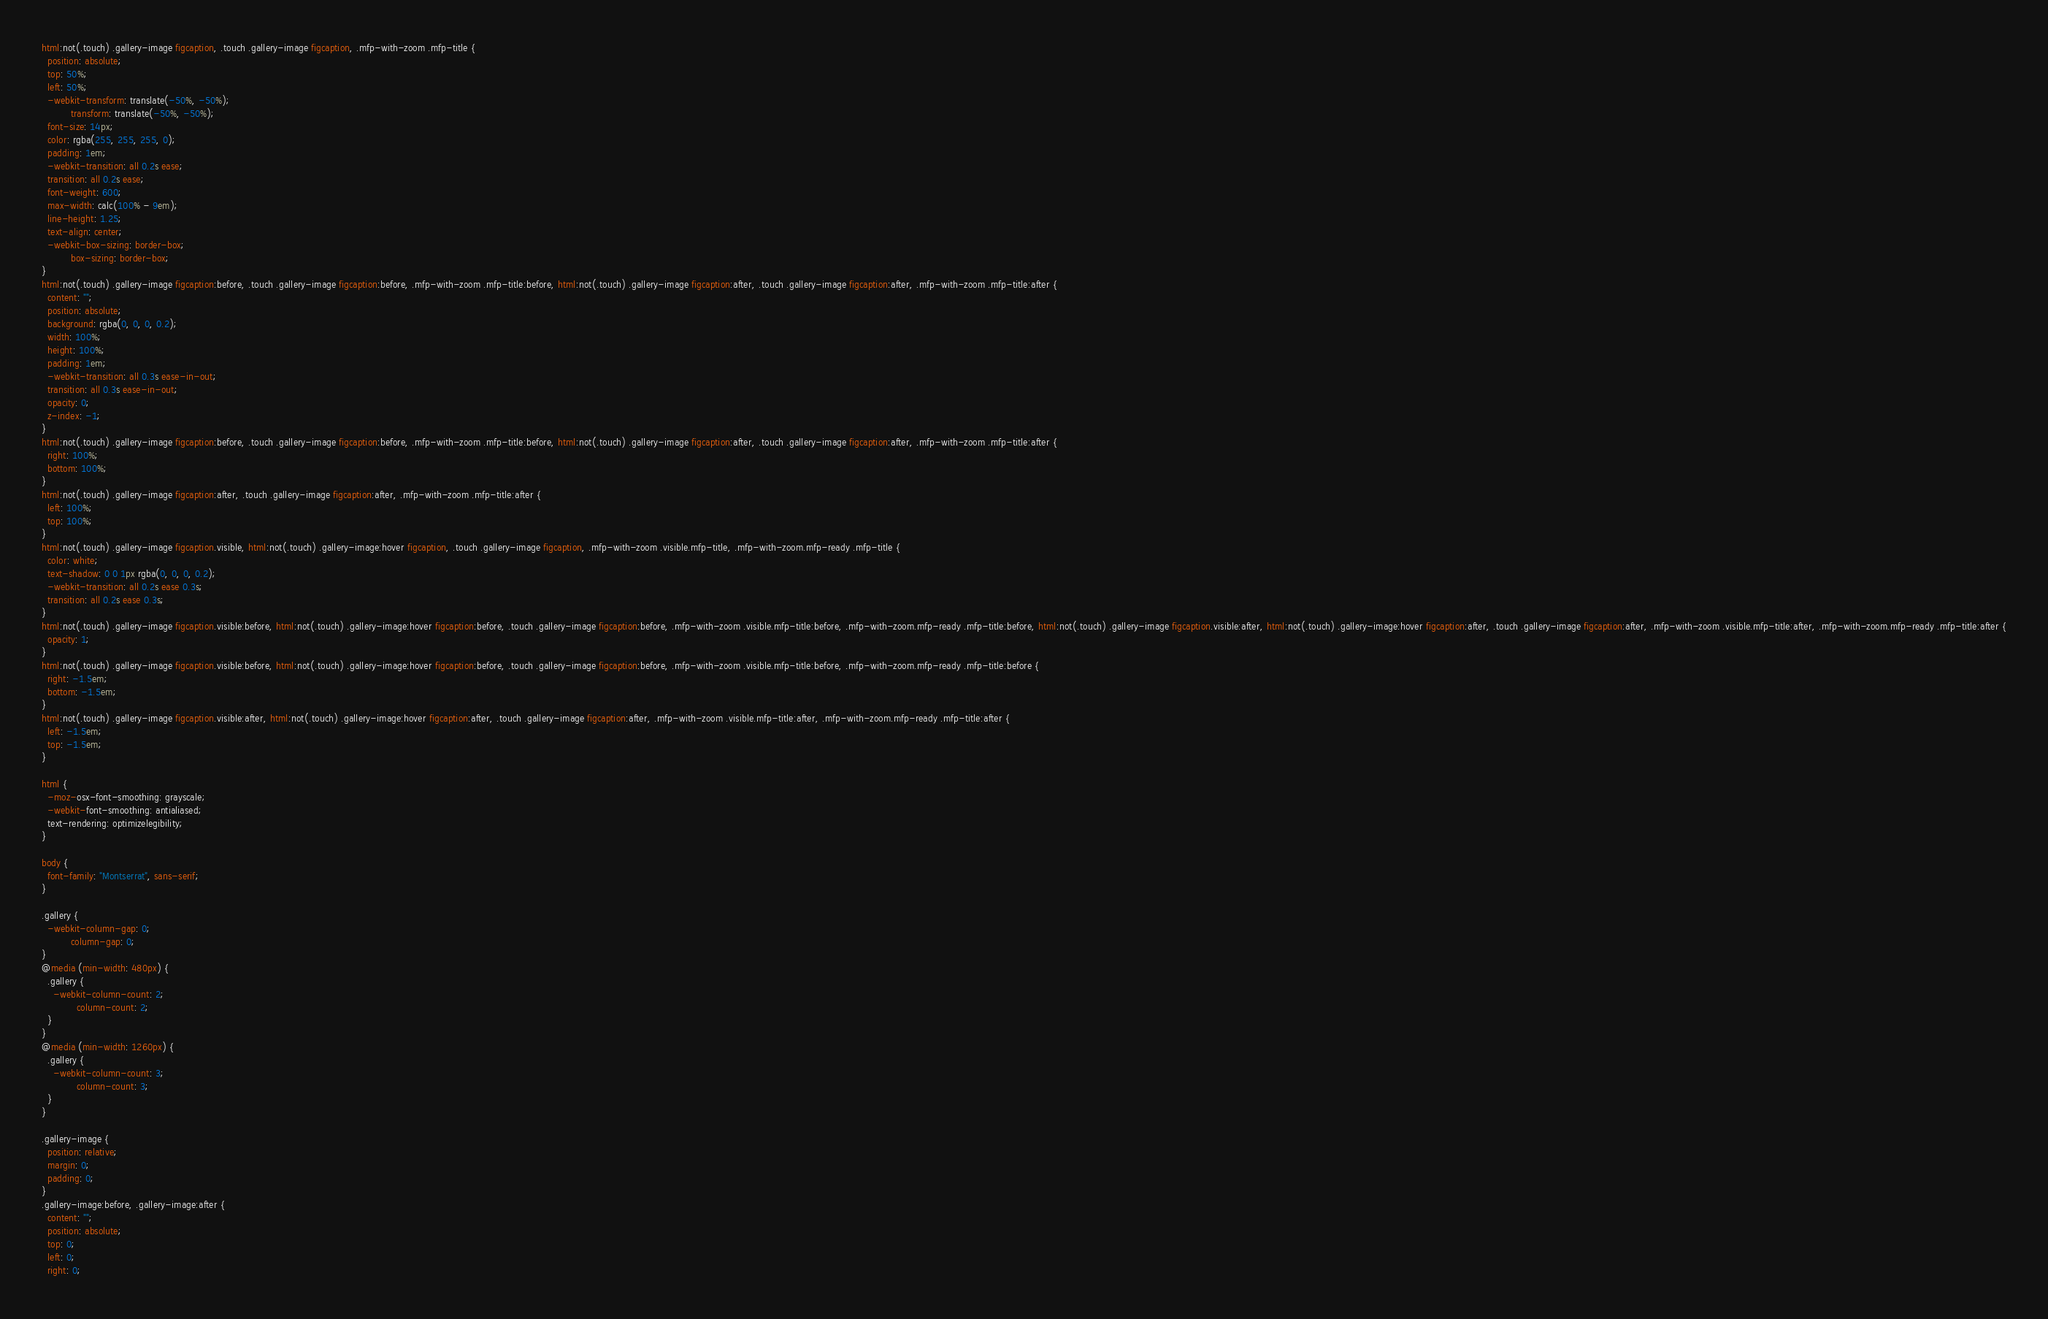Convert code to text. <code><loc_0><loc_0><loc_500><loc_500><_CSS_>html:not(.touch) .gallery-image figcaption, .touch .gallery-image figcaption, .mfp-with-zoom .mfp-title {
  position: absolute;
  top: 50%;
  left: 50%;
  -webkit-transform: translate(-50%, -50%);
          transform: translate(-50%, -50%);
  font-size: 14px;
  color: rgba(255, 255, 255, 0);
  padding: 1em;
  -webkit-transition: all 0.2s ease;
  transition: all 0.2s ease;
  font-weight: 600;
  max-width: calc(100% - 9em);
  line-height: 1.25;
  text-align: center;
  -webkit-box-sizing: border-box;
          box-sizing: border-box;
}
html:not(.touch) .gallery-image figcaption:before, .touch .gallery-image figcaption:before, .mfp-with-zoom .mfp-title:before, html:not(.touch) .gallery-image figcaption:after, .touch .gallery-image figcaption:after, .mfp-with-zoom .mfp-title:after {
  content: "";
  position: absolute;
  background: rgba(0, 0, 0, 0.2);
  width: 100%;
  height: 100%;
  padding: 1em;
  -webkit-transition: all 0.3s ease-in-out;
  transition: all 0.3s ease-in-out;
  opacity: 0;
  z-index: -1;
}
html:not(.touch) .gallery-image figcaption:before, .touch .gallery-image figcaption:before, .mfp-with-zoom .mfp-title:before, html:not(.touch) .gallery-image figcaption:after, .touch .gallery-image figcaption:after, .mfp-with-zoom .mfp-title:after {
  right: 100%;
  bottom: 100%;
}
html:not(.touch) .gallery-image figcaption:after, .touch .gallery-image figcaption:after, .mfp-with-zoom .mfp-title:after {
  left: 100%;
  top: 100%;
}
html:not(.touch) .gallery-image figcaption.visible, html:not(.touch) .gallery-image:hover figcaption, .touch .gallery-image figcaption, .mfp-with-zoom .visible.mfp-title, .mfp-with-zoom.mfp-ready .mfp-title {
  color: white;
  text-shadow: 0 0 1px rgba(0, 0, 0, 0.2);
  -webkit-transition: all 0.2s ease 0.3s;
  transition: all 0.2s ease 0.3s;
}
html:not(.touch) .gallery-image figcaption.visible:before, html:not(.touch) .gallery-image:hover figcaption:before, .touch .gallery-image figcaption:before, .mfp-with-zoom .visible.mfp-title:before, .mfp-with-zoom.mfp-ready .mfp-title:before, html:not(.touch) .gallery-image figcaption.visible:after, html:not(.touch) .gallery-image:hover figcaption:after, .touch .gallery-image figcaption:after, .mfp-with-zoom .visible.mfp-title:after, .mfp-with-zoom.mfp-ready .mfp-title:after {
  opacity: 1;
}
html:not(.touch) .gallery-image figcaption.visible:before, html:not(.touch) .gallery-image:hover figcaption:before, .touch .gallery-image figcaption:before, .mfp-with-zoom .visible.mfp-title:before, .mfp-with-zoom.mfp-ready .mfp-title:before {
  right: -1.5em;
  bottom: -1.5em;
}
html:not(.touch) .gallery-image figcaption.visible:after, html:not(.touch) .gallery-image:hover figcaption:after, .touch .gallery-image figcaption:after, .mfp-with-zoom .visible.mfp-title:after, .mfp-with-zoom.mfp-ready .mfp-title:after {
  left: -1.5em;
  top: -1.5em;
}

html {
  -moz-osx-font-smoothing: grayscale;
  -webkit-font-smoothing: antialiased;
  text-rendering: optimizelegibility;
}

body {
  font-family: "Montserrat", sans-serif;
}

.gallery {
  -webkit-column-gap: 0;
          column-gap: 0;
}
@media (min-width: 480px) {
  .gallery {
    -webkit-column-count: 2;
            column-count: 2;
  }
}
@media (min-width: 1260px) {
  .gallery {
    -webkit-column-count: 3;
            column-count: 3;
  }
}

.gallery-image {
  position: relative;
  margin: 0;
  padding: 0;
}
.gallery-image:before, .gallery-image:after {
  content: "";
  position: absolute;
  top: 0;
  left: 0;
  right: 0;</code> 